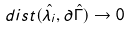Convert formula to latex. <formula><loc_0><loc_0><loc_500><loc_500>d i s t ( \hat { \lambda _ { i } } , \partial \hat { \Gamma } ) \rightarrow 0</formula> 